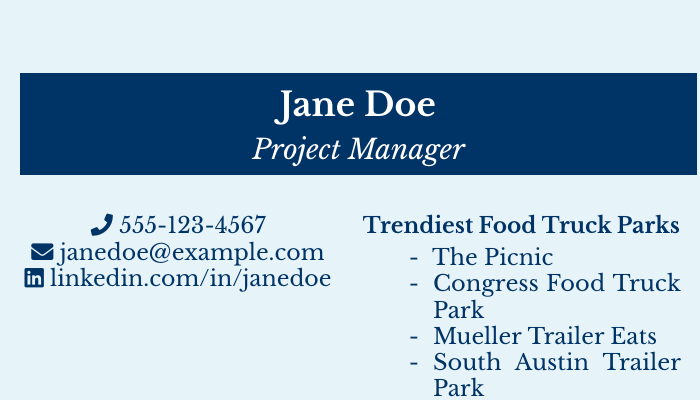What is the name on the business card? The name displayed prominently in the document is "Jane Doe."
Answer: Jane Doe What is the title of the individual? The title listed on the business card is "Project Manager."
Answer: Project Manager What is the contact phone number? The phone number provided on the card is 555-123-4567.
Answer: 555-123-4567 What is the email address? The email address given is "janedoe@example.com."
Answer: janedoe@example.com How many food truck parks are listed? There are four food truck parks mentioned in the document.
Answer: 4 Which food truck park is listed first? The first food truck park mentioned is "The Picnic."
Answer: The Picnic What is the background color of the business card? The background color is a light blue shade.
Answer: light blue What is the purpose statement on the card? The purpose statement written on the card is about scheduling lunch meetings at food truck parks.
Answer: Scheduling lunch meetings at the trendiest food truck parks in town What is the style of presentation for contact information? The contact information is presented using icons alongside the text.
Answer: Icons 